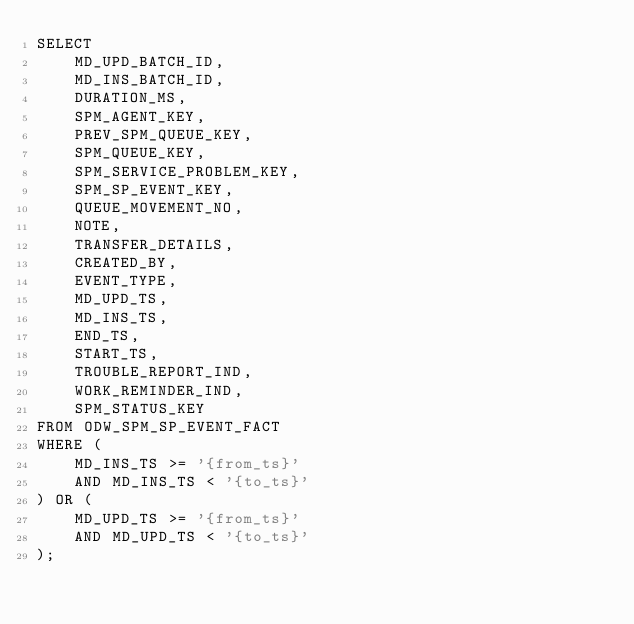Convert code to text. <code><loc_0><loc_0><loc_500><loc_500><_SQL_>SELECT 
    MD_UPD_BATCH_ID,
    MD_INS_BATCH_ID,
    DURATION_MS,
    SPM_AGENT_KEY,
    PREV_SPM_QUEUE_KEY,
    SPM_QUEUE_KEY,
    SPM_SERVICE_PROBLEM_KEY,
    SPM_SP_EVENT_KEY,
    QUEUE_MOVEMENT_NO,
    NOTE,
    TRANSFER_DETAILS,
    CREATED_BY,
    EVENT_TYPE,
    MD_UPD_TS,
    MD_INS_TS,
    END_TS,
    START_TS,
    TROUBLE_REPORT_IND,
    WORK_REMINDER_IND,
    SPM_STATUS_KEY
FROM ODW_SPM_SP_EVENT_FACT
WHERE (
    MD_INS_TS >= '{from_ts}'
    AND MD_INS_TS < '{to_ts}'
) OR (
    MD_UPD_TS >= '{from_ts}'
    AND MD_UPD_TS < '{to_ts}'
);
</code> 